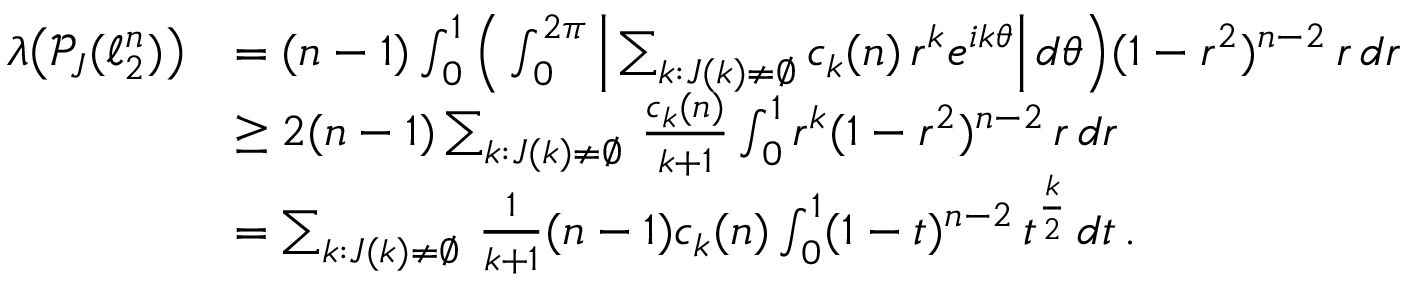Convert formula to latex. <formula><loc_0><loc_0><loc_500><loc_500>\begin{array} { r l } { \lambda \left ( \mathcal { P } _ { J } ( \ell _ { 2 } ^ { n } ) \right ) } & { = ( n - 1 ) \int _ { 0 } ^ { 1 } \left ( \int _ { 0 } ^ { 2 \pi } \left | \sum _ { k \colon J ( k ) \neq \emptyset } c _ { k } ( n ) \, r ^ { k } e ^ { i k \theta } \right | \, d \theta \right ) ( 1 - r ^ { 2 } ) ^ { n - 2 } \, r \, d r } \\ & { \geq 2 ( n - 1 ) \sum _ { k \colon J ( k ) \neq \emptyset } \, \frac { c _ { k } ( n ) } { k + 1 } \int _ { 0 } ^ { 1 } r ^ { k } ( 1 - r ^ { 2 } ) ^ { n - 2 } \, r \, d r } \\ & { = \sum _ { k \colon J ( k ) \neq \emptyset } \, \frac { 1 } { k + 1 } ( n - 1 ) c _ { k } ( n ) \int _ { 0 } ^ { 1 } ( 1 - t ) ^ { n - 2 } \, t ^ { \frac { k } { 2 } } \, d t \, . } \end{array}</formula> 